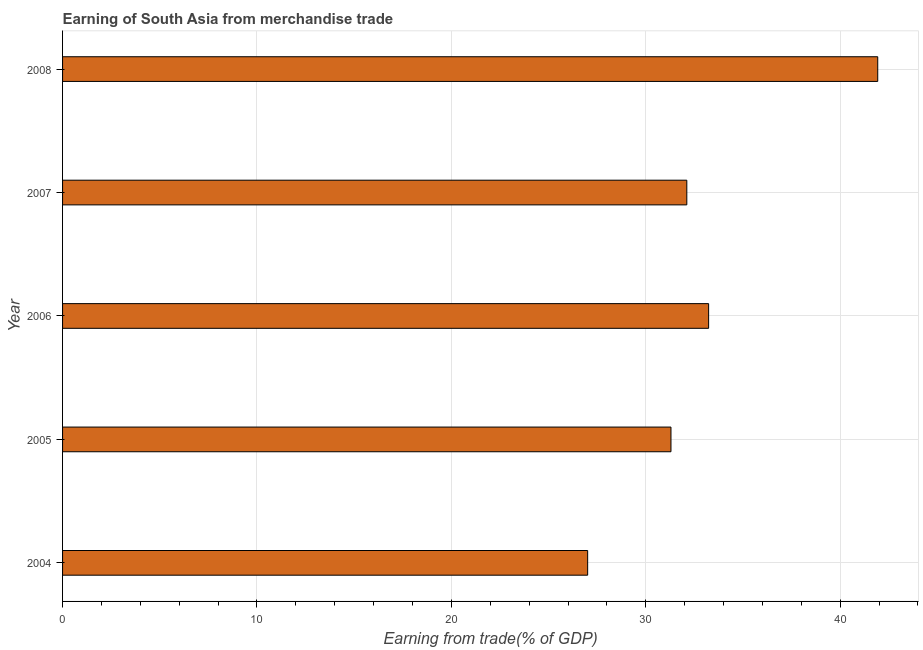Does the graph contain grids?
Keep it short and to the point. Yes. What is the title of the graph?
Offer a very short reply. Earning of South Asia from merchandise trade. What is the label or title of the X-axis?
Keep it short and to the point. Earning from trade(% of GDP). What is the earning from merchandise trade in 2007?
Give a very brief answer. 32.11. Across all years, what is the maximum earning from merchandise trade?
Your answer should be compact. 41.93. Across all years, what is the minimum earning from merchandise trade?
Your answer should be very brief. 27.01. In which year was the earning from merchandise trade maximum?
Your response must be concise. 2008. In which year was the earning from merchandise trade minimum?
Make the answer very short. 2004. What is the sum of the earning from merchandise trade?
Your answer should be very brief. 165.57. What is the difference between the earning from merchandise trade in 2004 and 2006?
Ensure brevity in your answer.  -6.22. What is the average earning from merchandise trade per year?
Offer a very short reply. 33.12. What is the median earning from merchandise trade?
Offer a very short reply. 32.11. In how many years, is the earning from merchandise trade greater than 4 %?
Offer a terse response. 5. Do a majority of the years between 2008 and 2005 (inclusive) have earning from merchandise trade greater than 34 %?
Provide a succinct answer. Yes. What is the ratio of the earning from merchandise trade in 2007 to that in 2008?
Provide a short and direct response. 0.77. Is the earning from merchandise trade in 2005 less than that in 2007?
Ensure brevity in your answer.  Yes. What is the difference between the highest and the second highest earning from merchandise trade?
Keep it short and to the point. 8.7. What is the difference between the highest and the lowest earning from merchandise trade?
Give a very brief answer. 14.92. In how many years, is the earning from merchandise trade greater than the average earning from merchandise trade taken over all years?
Provide a succinct answer. 2. How many bars are there?
Offer a very short reply. 5. Are all the bars in the graph horizontal?
Offer a terse response. Yes. How many years are there in the graph?
Offer a very short reply. 5. Are the values on the major ticks of X-axis written in scientific E-notation?
Ensure brevity in your answer.  No. What is the Earning from trade(% of GDP) of 2004?
Provide a succinct answer. 27.01. What is the Earning from trade(% of GDP) of 2005?
Make the answer very short. 31.29. What is the Earning from trade(% of GDP) of 2006?
Offer a very short reply. 33.23. What is the Earning from trade(% of GDP) in 2007?
Ensure brevity in your answer.  32.11. What is the Earning from trade(% of GDP) in 2008?
Offer a terse response. 41.93. What is the difference between the Earning from trade(% of GDP) in 2004 and 2005?
Keep it short and to the point. -4.28. What is the difference between the Earning from trade(% of GDP) in 2004 and 2006?
Your answer should be very brief. -6.22. What is the difference between the Earning from trade(% of GDP) in 2004 and 2007?
Your response must be concise. -5.1. What is the difference between the Earning from trade(% of GDP) in 2004 and 2008?
Provide a short and direct response. -14.92. What is the difference between the Earning from trade(% of GDP) in 2005 and 2006?
Provide a succinct answer. -1.94. What is the difference between the Earning from trade(% of GDP) in 2005 and 2007?
Give a very brief answer. -0.81. What is the difference between the Earning from trade(% of GDP) in 2005 and 2008?
Your response must be concise. -10.64. What is the difference between the Earning from trade(% of GDP) in 2006 and 2007?
Provide a short and direct response. 1.12. What is the difference between the Earning from trade(% of GDP) in 2006 and 2008?
Your answer should be compact. -8.7. What is the difference between the Earning from trade(% of GDP) in 2007 and 2008?
Provide a succinct answer. -9.82. What is the ratio of the Earning from trade(% of GDP) in 2004 to that in 2005?
Your answer should be compact. 0.86. What is the ratio of the Earning from trade(% of GDP) in 2004 to that in 2006?
Offer a very short reply. 0.81. What is the ratio of the Earning from trade(% of GDP) in 2004 to that in 2007?
Offer a very short reply. 0.84. What is the ratio of the Earning from trade(% of GDP) in 2004 to that in 2008?
Give a very brief answer. 0.64. What is the ratio of the Earning from trade(% of GDP) in 2005 to that in 2006?
Keep it short and to the point. 0.94. What is the ratio of the Earning from trade(% of GDP) in 2005 to that in 2007?
Provide a succinct answer. 0.97. What is the ratio of the Earning from trade(% of GDP) in 2005 to that in 2008?
Your response must be concise. 0.75. What is the ratio of the Earning from trade(% of GDP) in 2006 to that in 2007?
Provide a short and direct response. 1.03. What is the ratio of the Earning from trade(% of GDP) in 2006 to that in 2008?
Your answer should be very brief. 0.79. What is the ratio of the Earning from trade(% of GDP) in 2007 to that in 2008?
Your response must be concise. 0.77. 